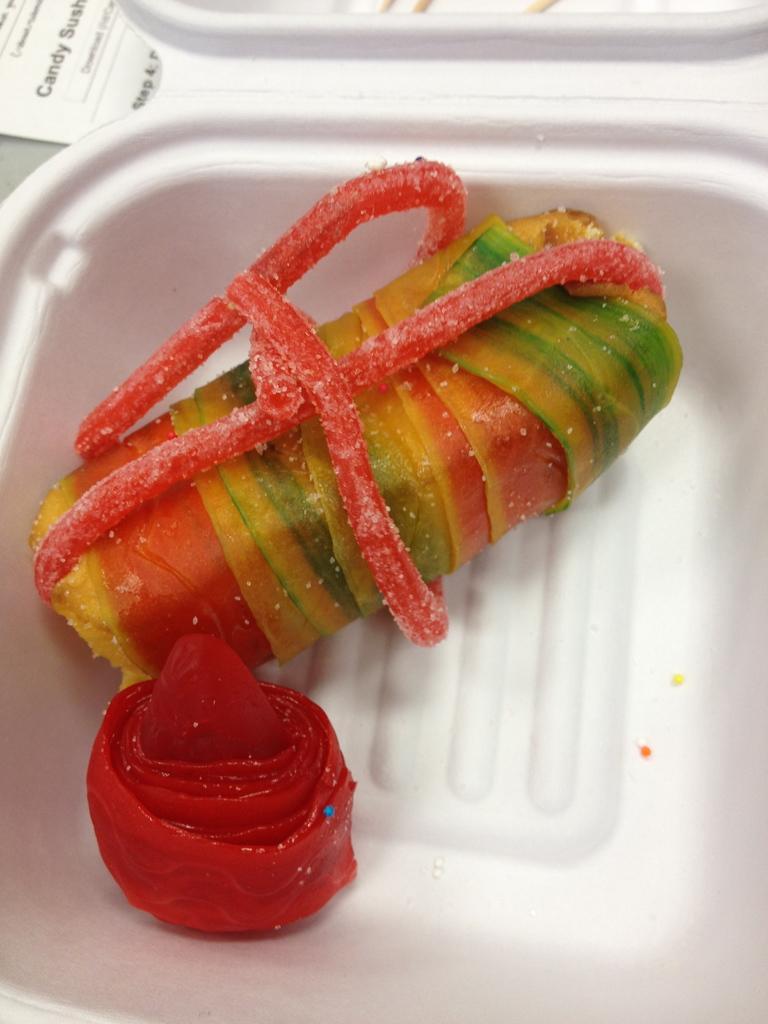How would you summarize this image in a sentence or two? In this image, we can see a bowl contains objects. 